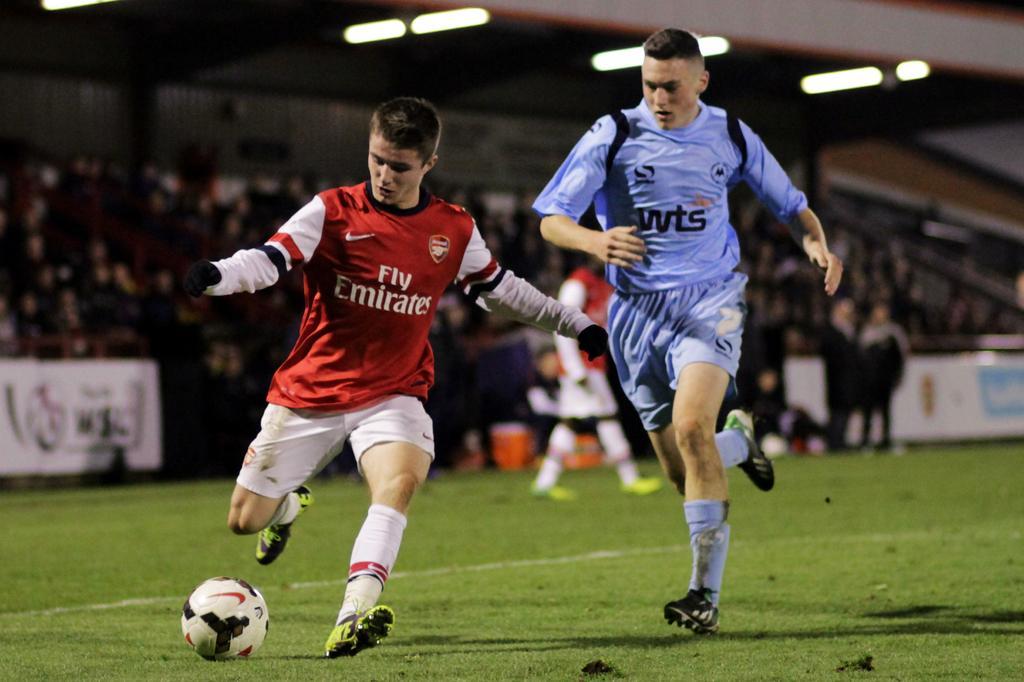Please provide a concise description of this image. there are two persons running on the ground there is a ball on the ground. 